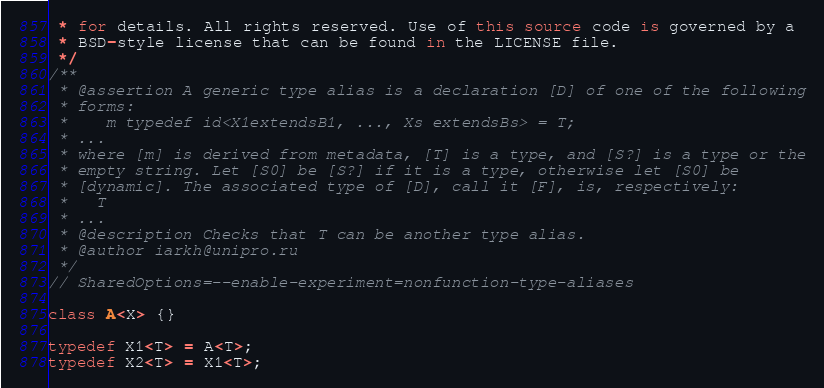<code> <loc_0><loc_0><loc_500><loc_500><_Dart_> * for details. All rights reserved. Use of this source code is governed by a
 * BSD-style license that can be found in the LICENSE file.
 */
/**
 * @assertion A generic type alias is a declaration [D] of one of the following
 * forms:
 *    m typedef id<X1extendsB1, ..., Xs extendsBs> = T;
 * ...
 * where [m] is derived from metadata, [T] is a type, and [S?] is a type or the
 * empty string. Let [S0] be [S?] if it is a type, otherwise let [S0] be
 * [dynamic]. The associated type of [D], call it [F], is, respectively:
 *   T
 * ...
 * @description Checks that T can be another type alias.
 * @author iarkh@unipro.ru
 */
// SharedOptions=--enable-experiment=nonfunction-type-aliases

class A<X> {}

typedef X1<T> = A<T>;
typedef X2<T> = X1<T>;
</code> 